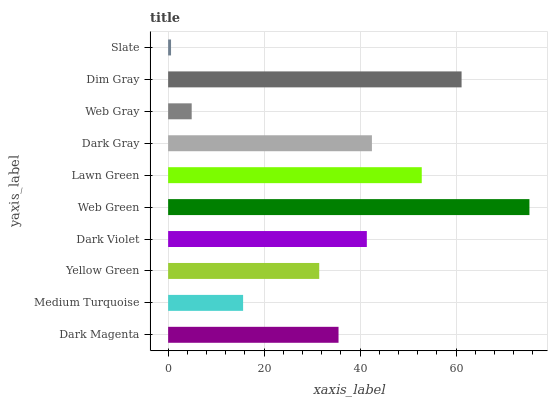Is Slate the minimum?
Answer yes or no. Yes. Is Web Green the maximum?
Answer yes or no. Yes. Is Medium Turquoise the minimum?
Answer yes or no. No. Is Medium Turquoise the maximum?
Answer yes or no. No. Is Dark Magenta greater than Medium Turquoise?
Answer yes or no. Yes. Is Medium Turquoise less than Dark Magenta?
Answer yes or no. Yes. Is Medium Turquoise greater than Dark Magenta?
Answer yes or no. No. Is Dark Magenta less than Medium Turquoise?
Answer yes or no. No. Is Dark Violet the high median?
Answer yes or no. Yes. Is Dark Magenta the low median?
Answer yes or no. Yes. Is Medium Turquoise the high median?
Answer yes or no. No. Is Dim Gray the low median?
Answer yes or no. No. 